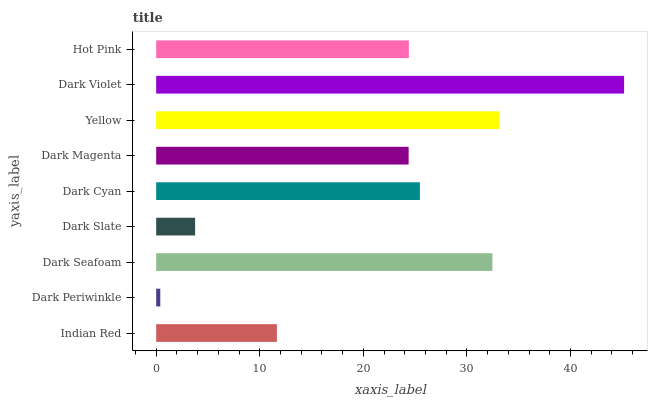Is Dark Periwinkle the minimum?
Answer yes or no. Yes. Is Dark Violet the maximum?
Answer yes or no. Yes. Is Dark Seafoam the minimum?
Answer yes or no. No. Is Dark Seafoam the maximum?
Answer yes or no. No. Is Dark Seafoam greater than Dark Periwinkle?
Answer yes or no. Yes. Is Dark Periwinkle less than Dark Seafoam?
Answer yes or no. Yes. Is Dark Periwinkle greater than Dark Seafoam?
Answer yes or no. No. Is Dark Seafoam less than Dark Periwinkle?
Answer yes or no. No. Is Hot Pink the high median?
Answer yes or no. Yes. Is Hot Pink the low median?
Answer yes or no. Yes. Is Indian Red the high median?
Answer yes or no. No. Is Dark Magenta the low median?
Answer yes or no. No. 